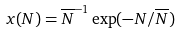<formula> <loc_0><loc_0><loc_500><loc_500>x ( N ) = { \overline { N } } ^ { - 1 } \exp ( - N / { \overline { N } } )</formula> 